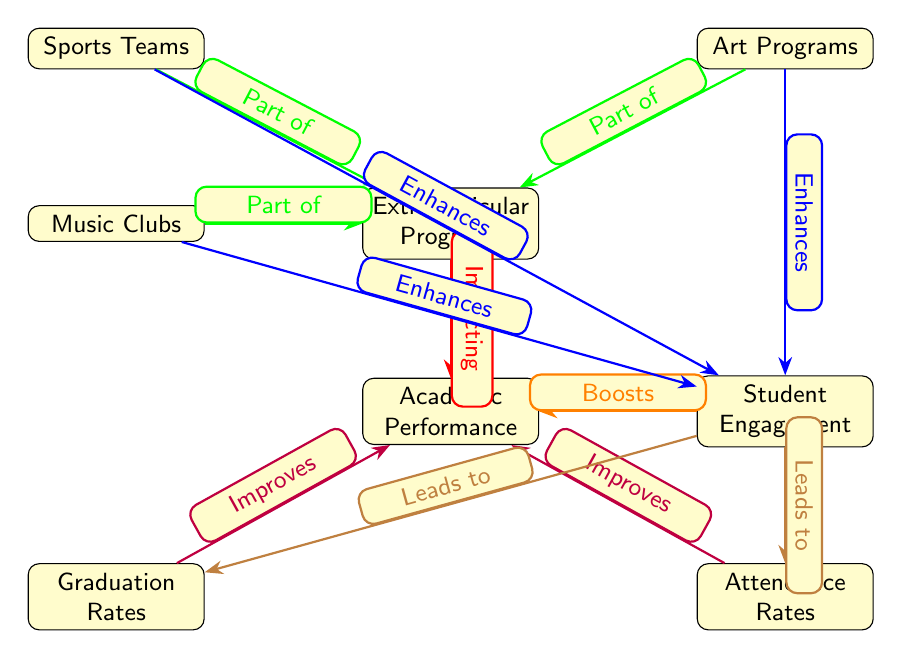What is the central node in the diagram? The central node in the diagram is "Extracurricular Programs" as it is positioned in the middle and connects to multiple other nodes.
Answer: Extracurricular Programs How many edges connect to "Academic Performance"? The node "Academic Performance" has three edges connecting to it, leading from "Extracurricular Programs," "Student Engagement," "Graduation Rates," and "Attendance Rates."
Answer: 4 What type of relationship is shown between "Sports Teams" and "Extracurricular Programs"? The diagram indicates a "Part of" relationship between "Sports Teams" and "Extracurricular Programs," suggesting that sports teams are included within extracurricular programs.
Answer: Part of Which node leads to "Graduation Rates"? The node "Student Engagement" leads to "Graduation Rates," as indicated by the arrow coming from "Student Engagement" to "Graduation Rates."
Answer: Student Engagement What do the orange edges indicate in the diagram? The orange edges show that "Student Engagement" boosts "Academic Performance," highlighting the positive impact of engagement on academic success.
Answer: Boosts How do "Music Clubs," "Art Programs," and "Sports Teams" interact with "Student Engagement"? All three nodes, "Music Clubs," "Art Programs," and "Sports Teams," enhance "Student Engagement," as shown by the blue arrows pointing from each of these programs to "Student Engagement."
Answer: Enhances How does "Attendance Rates" relate to "Academic Performance"? "Attendance Rates" improve "Academic Performance," implying that better attendance positively affects students' academic results, as per the purple edge linking them.
Answer: Improves What effect do extracurricular programs have on graduation rates? Extracurricular programs, through their impact on student engagement, ultimately lead to improved graduation rates, as depicted by the connection from "Student Engagement" to "Graduation Rates."
Answer: Improves How many extracurricular program types are identified in the diagram? The diagram identifies three types of extracurricular programs: "Sports Teams," "Music Clubs," and "Art Programs."
Answer: 3 